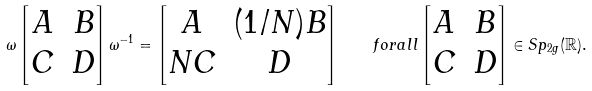Convert formula to latex. <formula><loc_0><loc_0><loc_500><loc_500>\omega \left [ \begin{matrix} A & B \\ C & D \end{matrix} \right ] \omega ^ { - 1 } = \left [ \begin{matrix} A & ( 1 / N ) B \\ N C & D \end{matrix} \right ] \quad f o r a l l \left [ \begin{matrix} A & B \\ C & D \end{matrix} \right ] \in S p _ { 2 g } ( \mathbb { R } ) .</formula> 